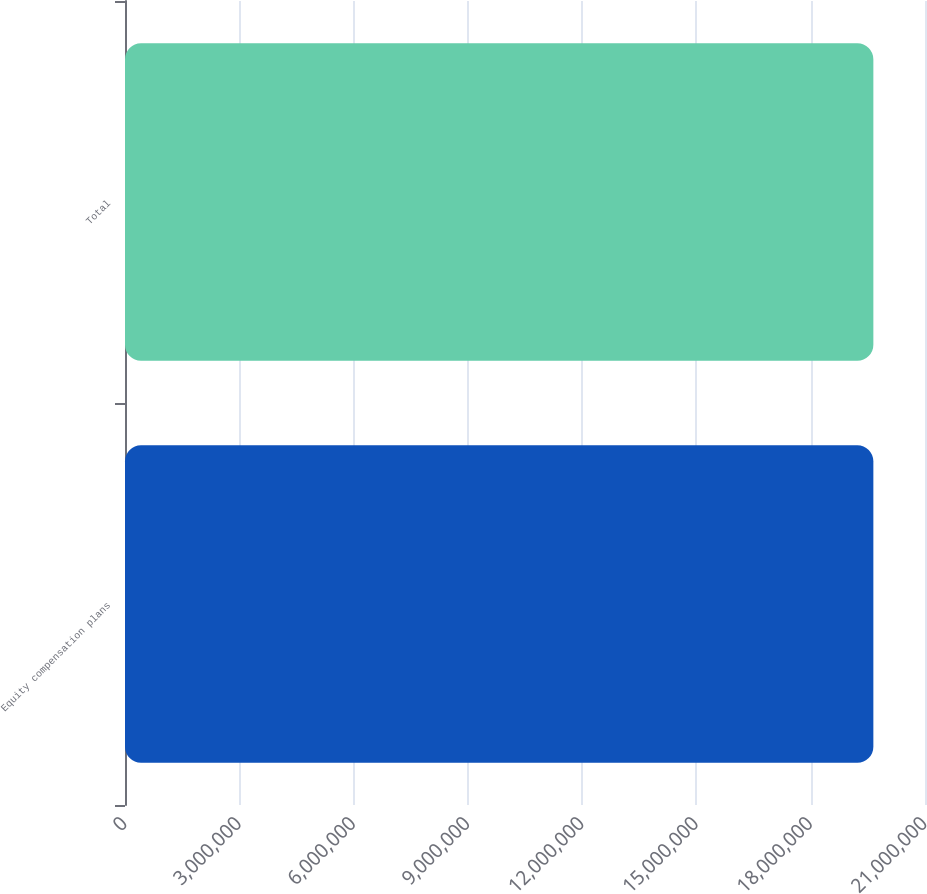Convert chart. <chart><loc_0><loc_0><loc_500><loc_500><bar_chart><fcel>Equity compensation plans<fcel>Total<nl><fcel>1.96443e+07<fcel>1.96443e+07<nl></chart> 